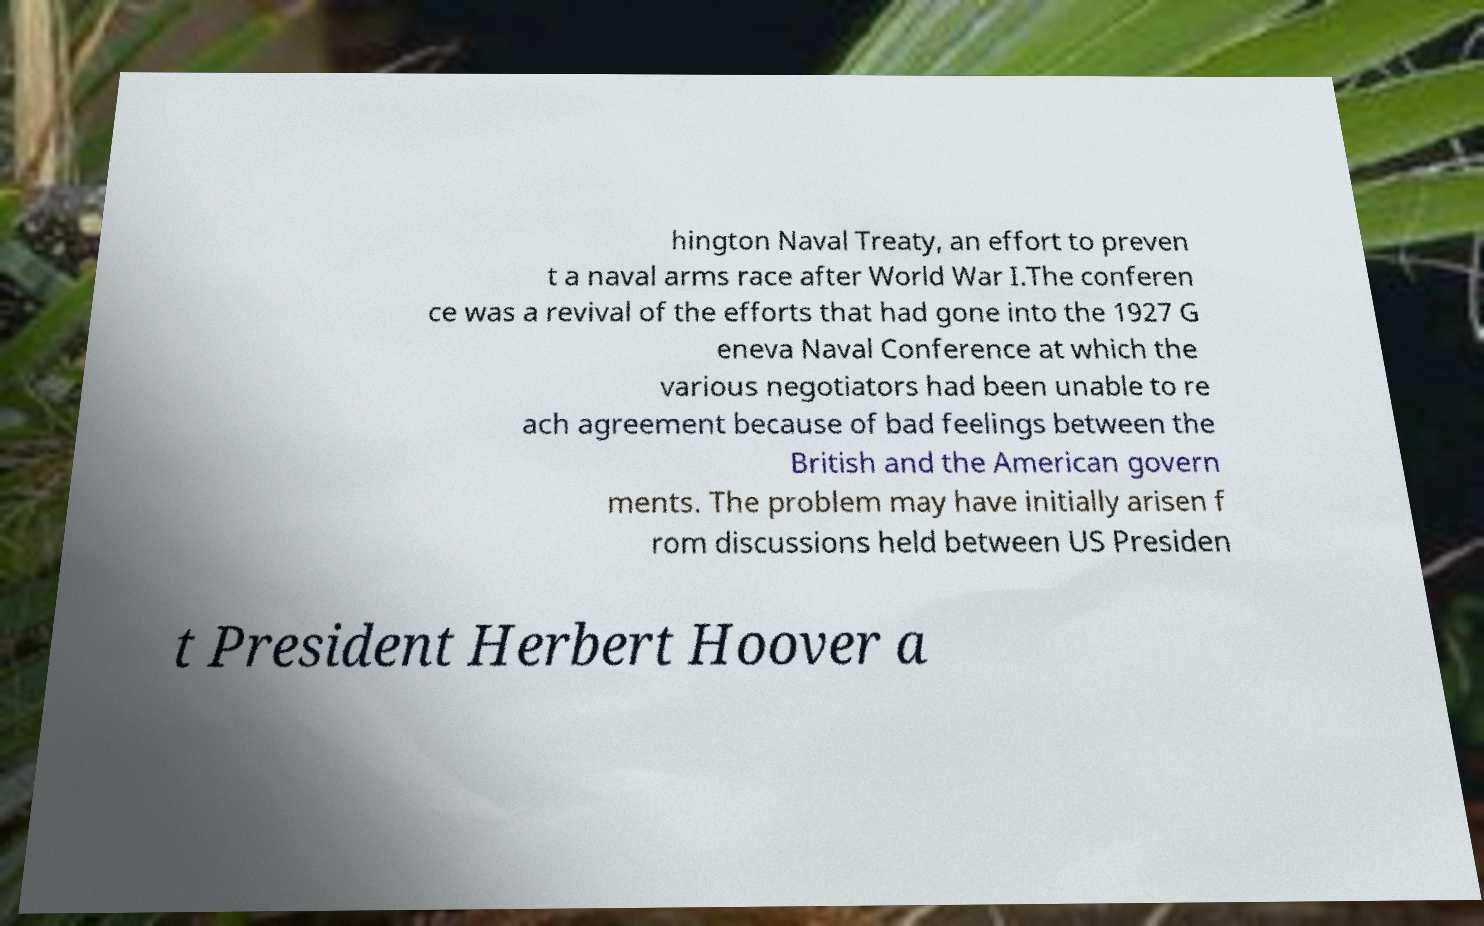There's text embedded in this image that I need extracted. Can you transcribe it verbatim? hington Naval Treaty, an effort to preven t a naval arms race after World War I.The conferen ce was a revival of the efforts that had gone into the 1927 G eneva Naval Conference at which the various negotiators had been unable to re ach agreement because of bad feelings between the British and the American govern ments. The problem may have initially arisen f rom discussions held between US Presiden t President Herbert Hoover a 